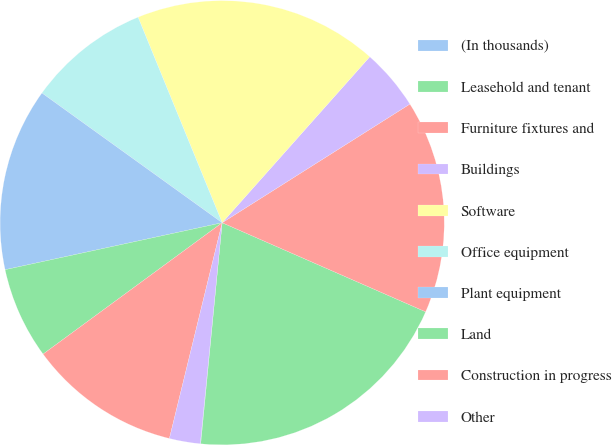Convert chart to OTSL. <chart><loc_0><loc_0><loc_500><loc_500><pie_chart><fcel>(In thousands)<fcel>Leasehold and tenant<fcel>Furniture fixtures and<fcel>Buildings<fcel>Software<fcel>Office equipment<fcel>Plant equipment<fcel>Land<fcel>Construction in progress<fcel>Other<nl><fcel>0.03%<fcel>19.97%<fcel>15.54%<fcel>4.46%<fcel>17.75%<fcel>8.89%<fcel>13.32%<fcel>6.68%<fcel>11.11%<fcel>2.25%<nl></chart> 